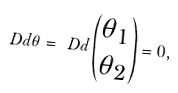Convert formula to latex. <formula><loc_0><loc_0><loc_500><loc_500>\ D d \theta = \ D d \begin{pmatrix} \theta _ { 1 } \\ \theta _ { 2 } \end{pmatrix} = 0 ,</formula> 